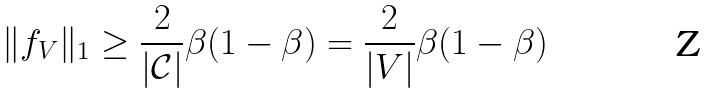<formula> <loc_0><loc_0><loc_500><loc_500>\| f _ { V } \| _ { 1 } \geq \frac { 2 } { | \mathcal { C } | } \beta ( 1 - \beta ) = \frac { 2 } { | V | } \beta ( 1 - \beta )</formula> 